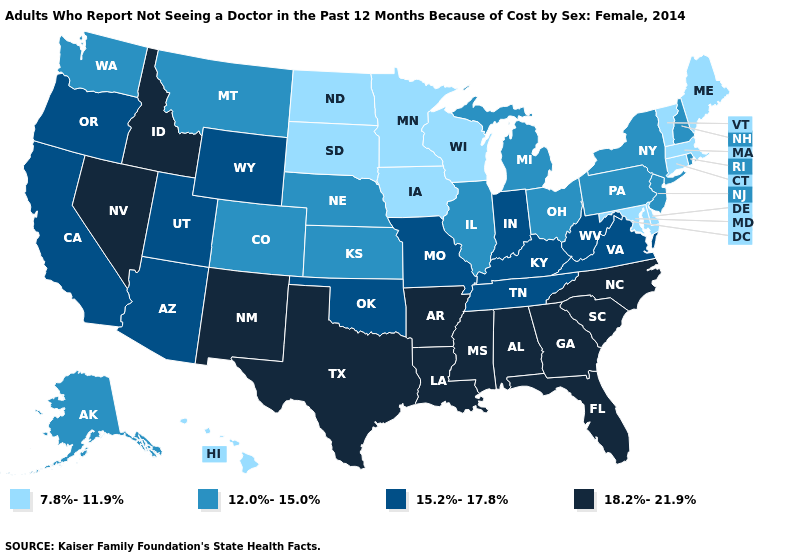Name the states that have a value in the range 7.8%-11.9%?
Give a very brief answer. Connecticut, Delaware, Hawaii, Iowa, Maine, Maryland, Massachusetts, Minnesota, North Dakota, South Dakota, Vermont, Wisconsin. What is the value of Oklahoma?
Answer briefly. 15.2%-17.8%. What is the value of Maryland?
Short answer required. 7.8%-11.9%. Does Indiana have the same value as Wyoming?
Keep it brief. Yes. Name the states that have a value in the range 7.8%-11.9%?
Keep it brief. Connecticut, Delaware, Hawaii, Iowa, Maine, Maryland, Massachusetts, Minnesota, North Dakota, South Dakota, Vermont, Wisconsin. Does South Dakota have the same value as Minnesota?
Write a very short answer. Yes. What is the value of Maryland?
Be succinct. 7.8%-11.9%. What is the lowest value in the USA?
Quick response, please. 7.8%-11.9%. What is the value of Pennsylvania?
Give a very brief answer. 12.0%-15.0%. Does New York have the lowest value in the USA?
Give a very brief answer. No. Does Nevada have a higher value than Mississippi?
Answer briefly. No. Does Ohio have a higher value than North Dakota?
Be succinct. Yes. Does Mississippi have the same value as South Carolina?
Answer briefly. Yes. Does Florida have the highest value in the USA?
Be succinct. Yes. Name the states that have a value in the range 15.2%-17.8%?
Concise answer only. Arizona, California, Indiana, Kentucky, Missouri, Oklahoma, Oregon, Tennessee, Utah, Virginia, West Virginia, Wyoming. 